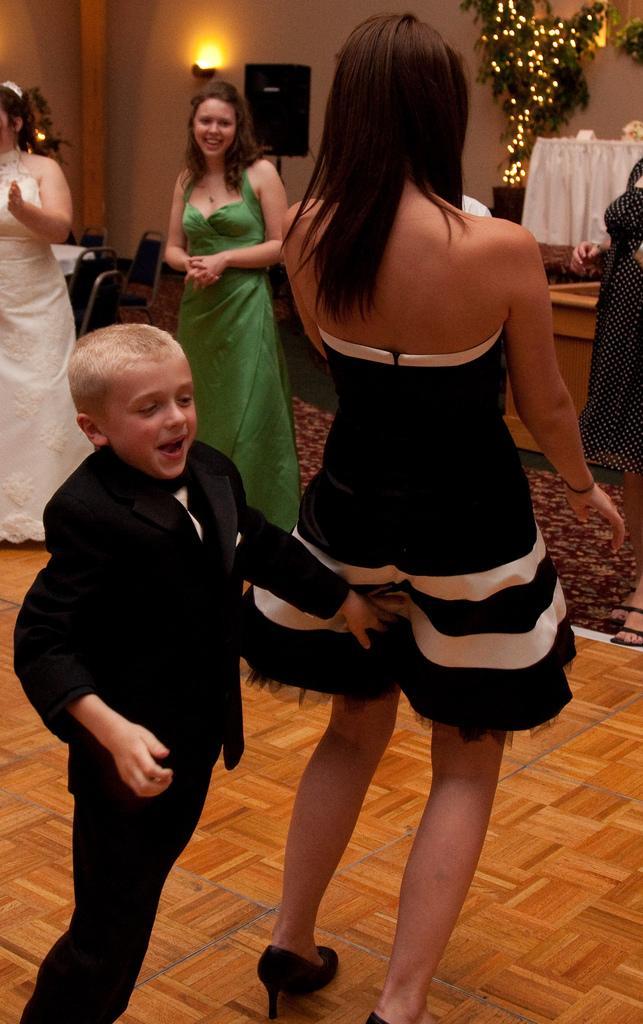Could you give a brief overview of what you see in this image? In this image, we can see a group of people are on the floor. Here we can see few people are smiling. Background there is a wall, few chairs, tables with cloth, speaker, lights, plant we can see. 